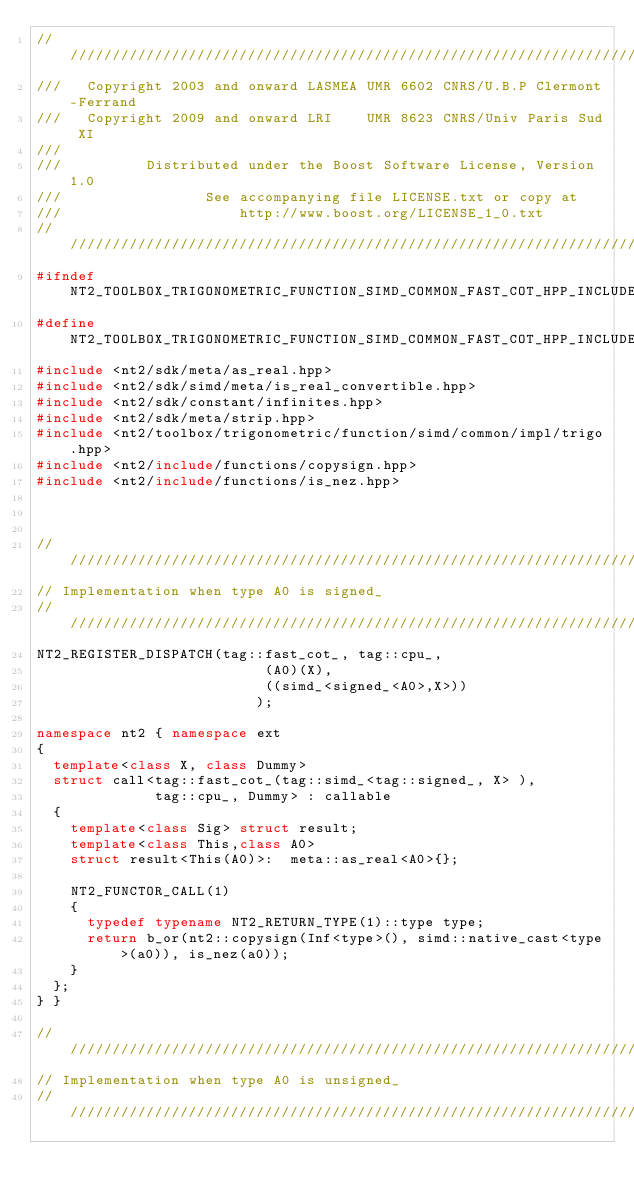Convert code to text. <code><loc_0><loc_0><loc_500><loc_500><_C++_>//////////////////////////////////////////////////////////////////////////////
///   Copyright 2003 and onward LASMEA UMR 6602 CNRS/U.B.P Clermont-Ferrand
///   Copyright 2009 and onward LRI    UMR 8623 CNRS/Univ Paris Sud XI
///
///          Distributed under the Boost Software License, Version 1.0
///                 See accompanying file LICENSE.txt or copy at
///                     http://www.boost.org/LICENSE_1_0.txt
//////////////////////////////////////////////////////////////////////////////
#ifndef NT2_TOOLBOX_TRIGONOMETRIC_FUNCTION_SIMD_COMMON_FAST_COT_HPP_INCLUDED
#define NT2_TOOLBOX_TRIGONOMETRIC_FUNCTION_SIMD_COMMON_FAST_COT_HPP_INCLUDED
#include <nt2/sdk/meta/as_real.hpp>
#include <nt2/sdk/simd/meta/is_real_convertible.hpp>
#include <nt2/sdk/constant/infinites.hpp>
#include <nt2/sdk/meta/strip.hpp>
#include <nt2/toolbox/trigonometric/function/simd/common/impl/trigo.hpp>
#include <nt2/include/functions/copysign.hpp>
#include <nt2/include/functions/is_nez.hpp>



/////////////////////////////////////////////////////////////////////////////
// Implementation when type A0 is signed_
/////////////////////////////////////////////////////////////////////////////
NT2_REGISTER_DISPATCH(tag::fast_cot_, tag::cpu_,
                           (A0)(X),
                           ((simd_<signed_<A0>,X>))
                          );

namespace nt2 { namespace ext
{
  template<class X, class Dummy>
  struct call<tag::fast_cot_(tag::simd_<tag::signed_, X> ),
              tag::cpu_, Dummy> : callable
  {
    template<class Sig> struct result;
    template<class This,class A0>
    struct result<This(A0)>:  meta::as_real<A0>{};

    NT2_FUNCTOR_CALL(1)
    {
      typedef typename NT2_RETURN_TYPE(1)::type type;
      return b_or(nt2::copysign(Inf<type>(), simd::native_cast<type>(a0)), is_nez(a0));
    }
  };
} }

/////////////////////////////////////////////////////////////////////////////
// Implementation when type A0 is unsigned_
/////////////////////////////////////////////////////////////////////////////</code> 